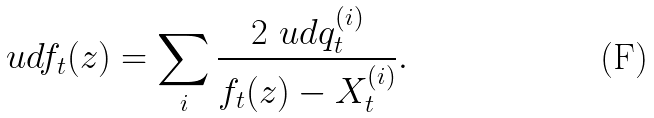Convert formula to latex. <formula><loc_0><loc_0><loc_500><loc_500>\ u d f _ { t } ( z ) = \sum _ { i } \frac { 2 \ u d q ^ { ( i ) } _ { t } } { f _ { t } ( z ) - X ^ { ( i ) } _ { t } } .</formula> 